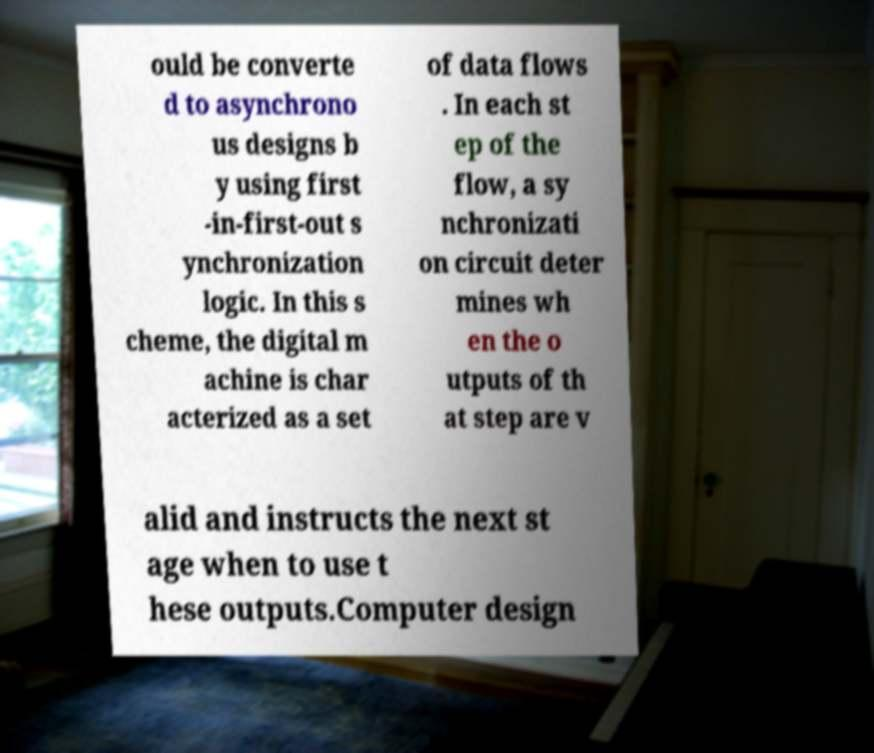For documentation purposes, I need the text within this image transcribed. Could you provide that? ould be converte d to asynchrono us designs b y using first -in-first-out s ynchronization logic. In this s cheme, the digital m achine is char acterized as a set of data flows . In each st ep of the flow, a sy nchronizati on circuit deter mines wh en the o utputs of th at step are v alid and instructs the next st age when to use t hese outputs.Computer design 